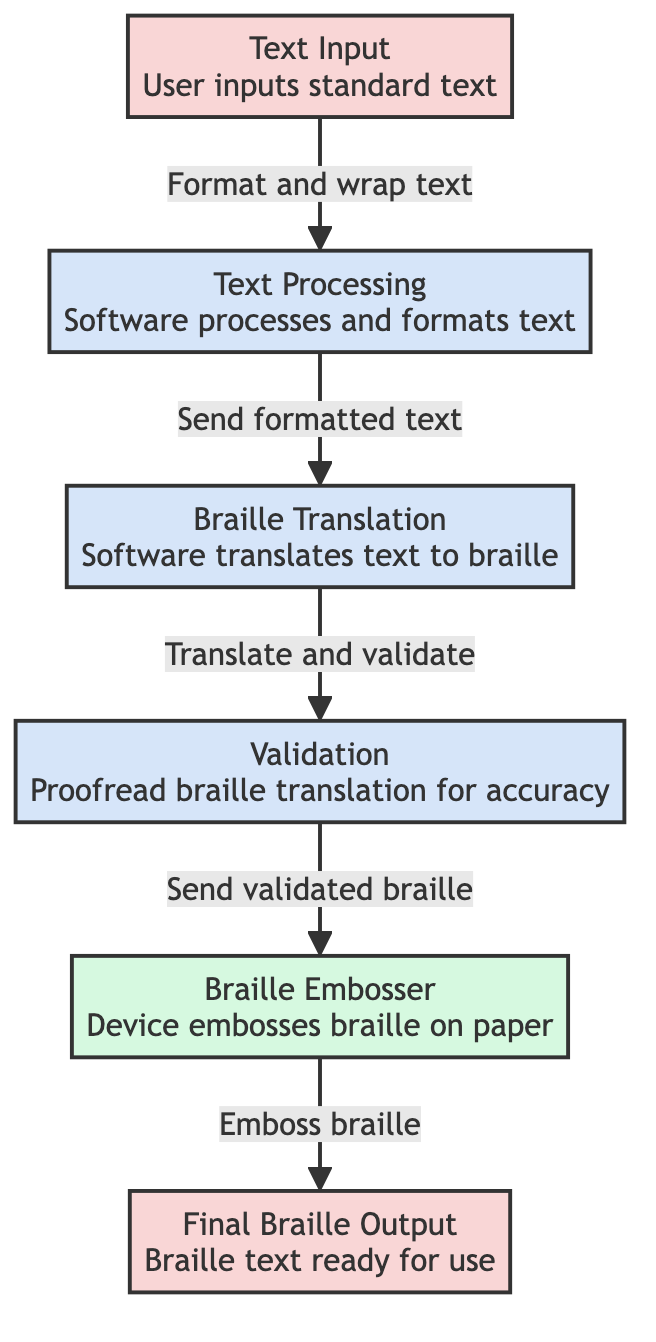What is the first step in the process? The diagram shows that the first step is "Text Input," where the user inputs standard text.
Answer: Text Input How many nodes are present in the diagram? The diagram includes six nodes: Text Input, Text Processing, Braille Translation, Validation, Braille Embosser, and Final Braille Output.
Answer: Six What connects "Text Processing" and "Braille Translation"? The connection between these two nodes is labeled "Send formatted text," indicating that processed text is sent to the Braille Translation step.
Answer: Send formatted text Which step involves proofreading? The node labeled "Validation" is the only step dedicated to proofreading the braille translation for accuracy.
Answer: Validation What is the output from the "Braille Embosser"? The final output from the Braille Embosser, as shown in the diagram, is "Final Braille Output," which is the embossed braille text ready for use.
Answer: Final Braille Output What is the main function of "Braille Translation"? The primary function indicated in the diagram for the Braille Translation step is to "Translate text to braille."
Answer: Translate text to braille Which node is categorized as a device? The "Braille Embosser" is categorized as a device in the diagram, specifically used for embossing braille on paper.
Answer: Braille Embosser What phase follows validation? The phase that follows validation is the "Braille Embosser," where the validated braille is embossed.
Answer: Braille Embosser How is text processed before translation? The processed text undergoes a step labeled "Format and wrap text" to prepare it for the Braille Translation.
Answer: Format and wrap text 